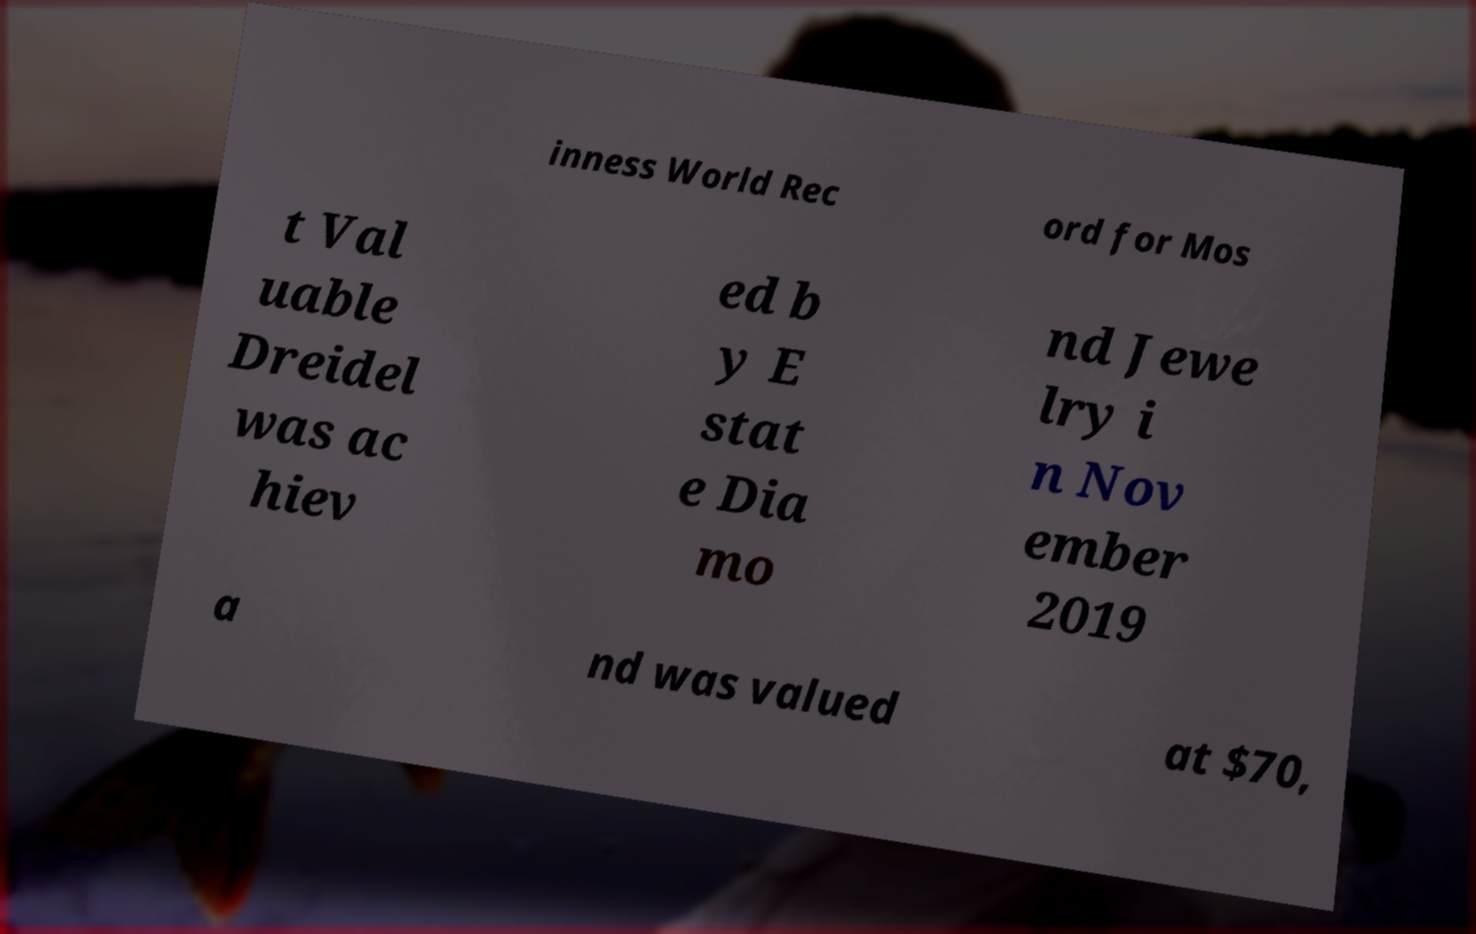Can you accurately transcribe the text from the provided image for me? inness World Rec ord for Mos t Val uable Dreidel was ac hiev ed b y E stat e Dia mo nd Jewe lry i n Nov ember 2019 a nd was valued at $70, 